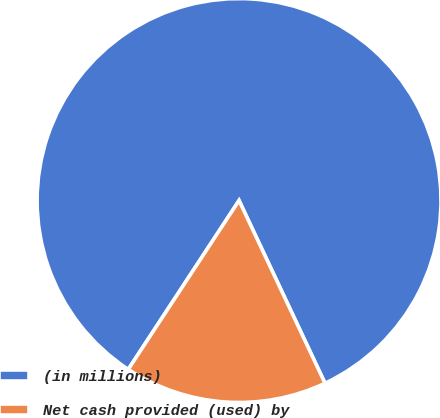Convert chart to OTSL. <chart><loc_0><loc_0><loc_500><loc_500><pie_chart><fcel>(in millions)<fcel>Net cash provided (used) by<nl><fcel>83.76%<fcel>16.24%<nl></chart> 